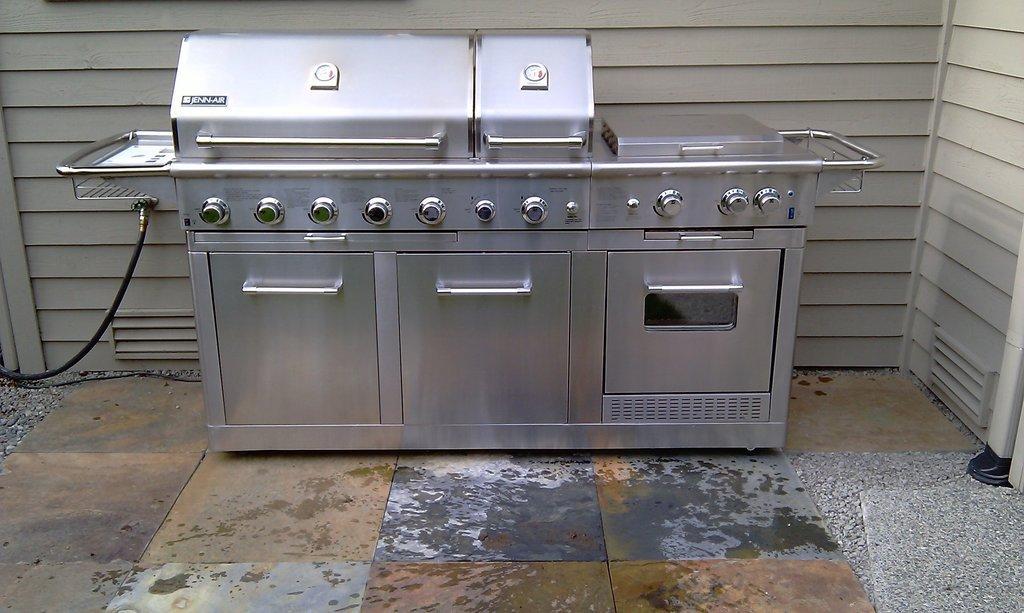Describe this image in one or two sentences. In this image in the center there is one machine, and there is some wire on the left side. At the bottom there is a walkway and some small stones, and in the background there is wall. 